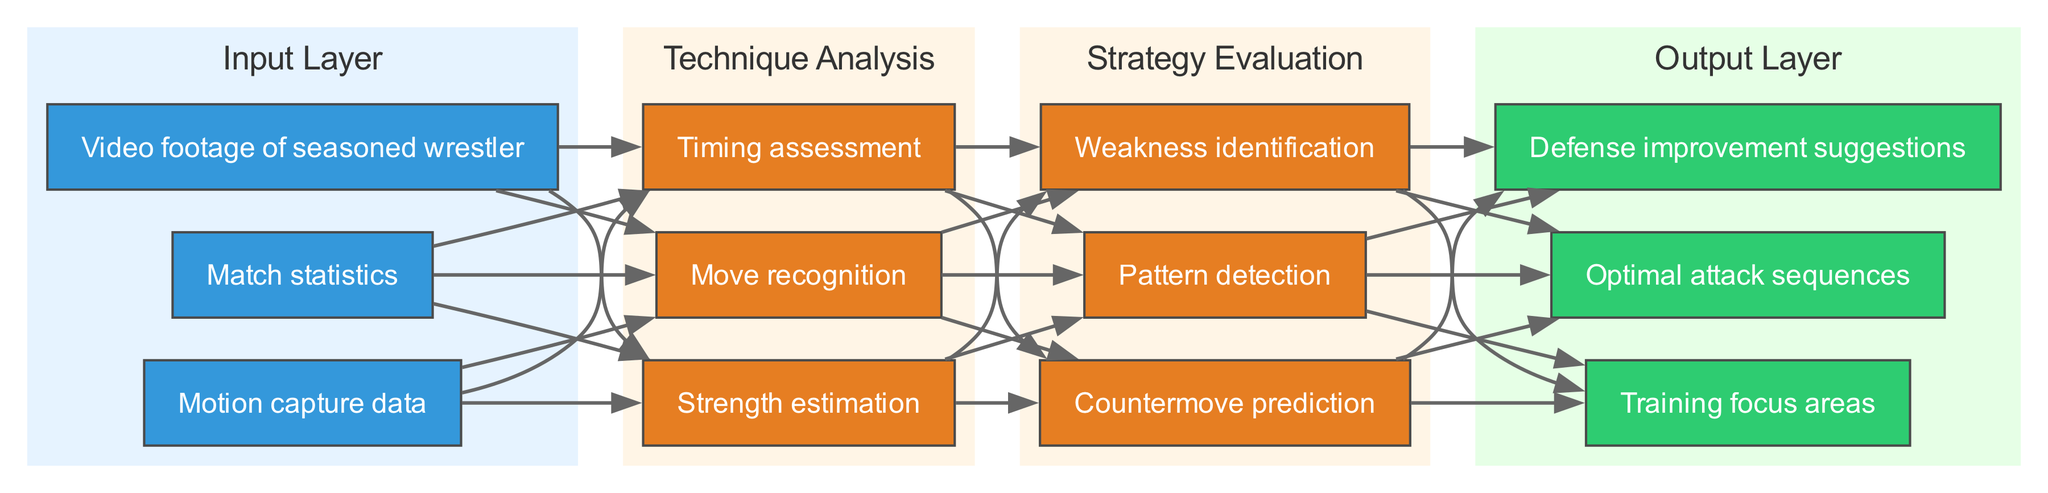What are the three types of input data? The diagram shows three inputs: "Video footage of seasoned wrestler", "Motion capture data", and "Match statistics".
Answer: Video footage of seasoned wrestler, Motion capture data, Match statistics How many nodes are in the "Technique Analysis" layer? The "Technique Analysis" layer contains three nodes: "Move recognition", "Timing assessment", and "Strength estimation". Therefore, the total is three.
Answer: 3 What type of data flows from the "Strategy Evaluation" to the "Output Layer"? The connections from the "Strategy Evaluation" to the "Output Layer" indicate that optimal attack sequences, defense improvement suggestions, and training focus areas are the output types.
Answer: Optimal attack sequences, Defense improvement suggestions, Training focus areas Which node directly follows the "Move recognition" node? The connection from "Technique Analysis" to "Strategy Evaluation" shows that the nodes in the "Strategy Evaluation" layer follow the nodes in the "Technique Analysis". Therefore, there is no direct follower since "Move recognition" is an input.
Answer: None What is the main purpose of the first hidden layer? The first hidden layer, labeled "Technique Analysis", is focused on analyzing wrestling techniques, such as move recognition and timing assessment, before evaluating strategies.
Answer: Technique Analysis How many edges connect the input layer to the hidden layers? Each of the three input nodes connects to three nodes in the "Technique Analysis" layer, leading to a total of nine edges (3 inputs times 3 nodes in Technique Analysis).
Answer: 9 What is the first output generated by the neural network? The diagram indicates the first output of the network is "Optimal attack sequences", listed as the first item in the output layer.
Answer: Optimal attack sequences What connection exists between the "Strength estimation" and the outputs? The "Strength estimation" node contributes to the "Strategy Evaluation" layer where the outputs are determined. Thus, it is indirectly involved in generating the outputs, but does not connect directly to outputs.
Answer: Indirect connection via Strategy Evaluation How many hidden layers are present in the diagram? The diagram clearly shows there are two hidden layers: "Technique Analysis" and "Strategy Evaluation".
Answer: 2 